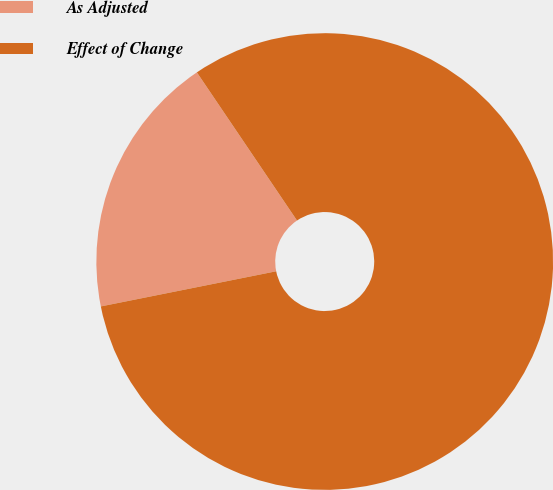<chart> <loc_0><loc_0><loc_500><loc_500><pie_chart><fcel>As Adjusted<fcel>Effect of Change<nl><fcel>18.69%<fcel>81.31%<nl></chart> 